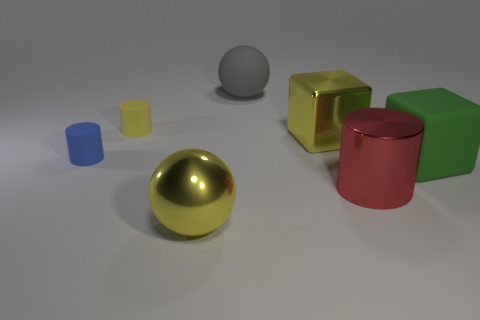Is there a cube of the same size as the blue rubber cylinder?
Ensure brevity in your answer.  No. What number of objects are either large spheres that are behind the large red thing or small objects that are to the left of the yellow rubber cylinder?
Give a very brief answer. 2. There is a thing that is the same size as the blue rubber cylinder; what is its shape?
Provide a succinct answer. Cylinder. Are there any other tiny blue things of the same shape as the blue thing?
Your answer should be very brief. No. Is the number of big yellow metal cubes less than the number of gray metallic cylinders?
Provide a short and direct response. No. There is a yellow shiny thing that is behind the big red metal thing; is it the same size as the thing to the left of the tiny yellow matte cylinder?
Provide a short and direct response. No. How many objects are large yellow cylinders or large gray spheres?
Offer a very short reply. 1. How big is the gray matte thing that is behind the red cylinder?
Provide a short and direct response. Large. What number of large gray things are to the left of the large metal object to the left of the block that is to the left of the large red thing?
Offer a terse response. 0. Do the big metal cube and the big metal cylinder have the same color?
Your answer should be compact. No. 